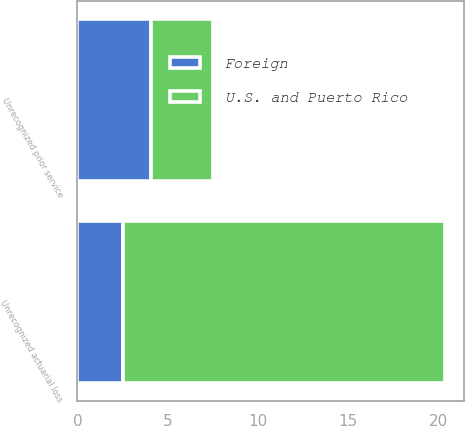Convert chart. <chart><loc_0><loc_0><loc_500><loc_500><stacked_bar_chart><ecel><fcel>Unrecognized prior service<fcel>Unrecognized actuarial loss<nl><fcel>U.S. and Puerto Rico<fcel>3.4<fcel>17.9<nl><fcel>Foreign<fcel>4.1<fcel>2.5<nl></chart> 